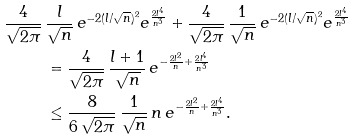<formula> <loc_0><loc_0><loc_500><loc_500>\frac { 4 } { \sqrt { 2 \pi } } \, & \frac { l } { \sqrt { n } } \, e ^ { - 2 ( l / \sqrt { n } ) ^ { 2 } } e ^ { \frac { 2 l ^ { 4 } } { n ^ { 3 } } } + \frac { 4 } { \sqrt { 2 \pi } } \, \frac { 1 } { \sqrt { n } } \, e ^ { - 2 ( l / \sqrt { n } ) ^ { 2 } } e ^ { \frac { 2 l ^ { 4 } } { n ^ { 3 } } } \\ & = \frac { 4 } { \sqrt { 2 \pi } } \, \frac { l + 1 } { \sqrt { n } } \, e ^ { - \frac { 2 l ^ { 2 } } { n } + \frac { 2 l ^ { 4 } } { n ^ { 3 } } } \\ & \leq \frac { 8 } { 6 \, \sqrt { 2 \pi } } \, \frac { 1 } { \sqrt { n } } \, n \, e ^ { - \frac { 2 l ^ { 2 } } { n } + \frac { 2 l ^ { 4 } } { n ^ { 3 } } } .</formula> 